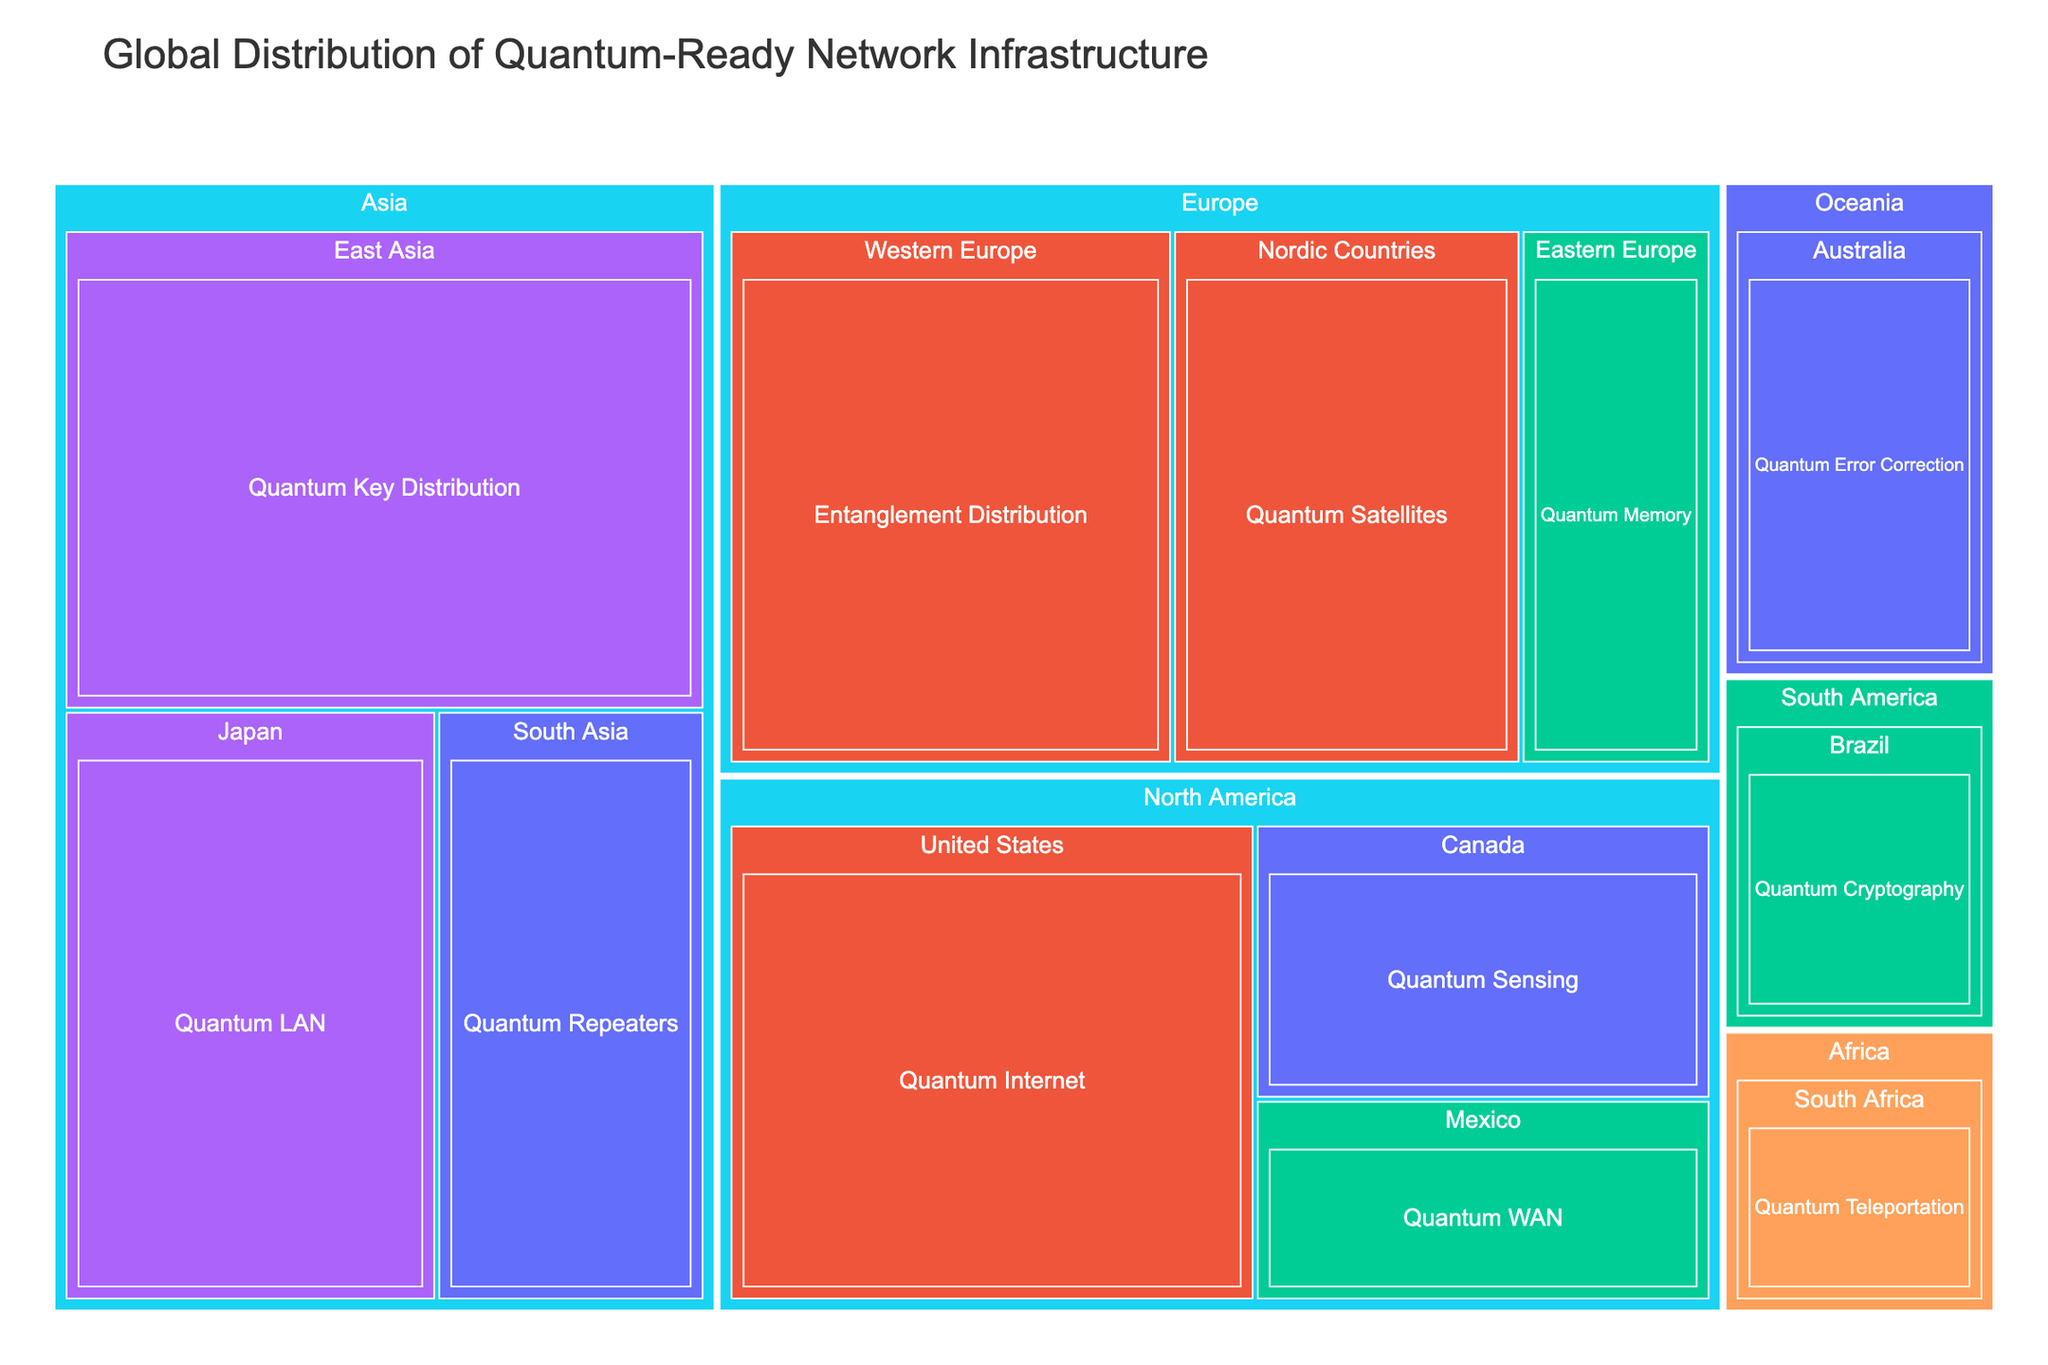What is the title of the Treemap? The title is usually found at the top of the Treemap and provides a summary of the information depicted. In this case, the title guides the viewer on what the Treemap represents.
Answer: Global Distribution of Quantum-Ready Network Infrastructure Which continent has the highest 'Technology Readiness Level' in 'Quantum Key Distribution'? Look for the 'Quantum Key Distribution' technology and identify the continent associated with the highest readiness level. East Asia, a region in Asia, has this technology with 'TRL 7'.
Answer: Asia How many regions are displayed in total across all continents? Count the number of distinct regions mentioned under each continent. The regions are East Asia, South Asia, Western Europe, Eastern Europe, United States, Canada, Brazil, South Africa, Australia, Nordic Countries, and Japan.
Answer: 11 Which continent has the smallest value for any of the technologies and what is that value? By examining the values associated with each technology and continent, find the smallest value. The smallest value is 8, associated with South Africa in Africa for 'Quantum Teleportation'.
Answer: Africa, 8 What is the combined value of all quantum technologies in North America? Locate each region in North America, add their values together: United States (30) + Canada (15) + Mexico (11). Thus, 30 + 15 + 11 = 56.
Answer: 56 Which technology has the highest readiness level and what is that level? Look for the technology with the maximum readiness level value. Both 'Quantum Key Distribution' in East Asia, Asia and 'Quantum LAN' in Japan, Asia have a 'TRL 7'.
Answer: Quantum Key Distribution/Quantum LAN, TRL 7 How does the value for 'Quantum Internet' in the United States compare to 'Entanglement Distribution' in Western Europe? Compare the values directly: 'Quantum Internet' in the United States is 30 and 'Entanglement Distribution' in Western Europe is 28.
Answer: Quantum Internet is higher What's the difference in value between 'Quantum Repeaters' in South Asia and 'Quantum Error Correction' in Australia? Subtract the value of 'Quantum Error Correction' in Australia from 'Quantum Repeaters' in South Asia: 18 - 14 = 4.
Answer: 4 How many different technologies are represented in Europe and what are they? Identify and count the unique technologies within the European regions: 'Entanglement Distribution', 'Quantum Memory', 'Quantum Satellites'. There are three technologies.
Answer: 3, Entanglement Distribution, Quantum Memory, Quantum Satellites In which continent and region is 'Quantum Cryptography' located and what is its value? Locate the 'Quantum Cryptography' entry and identify its continent, region, and value. It is located in South America, Brazil with a value of 10.
Answer: South America, Brazil, 10 